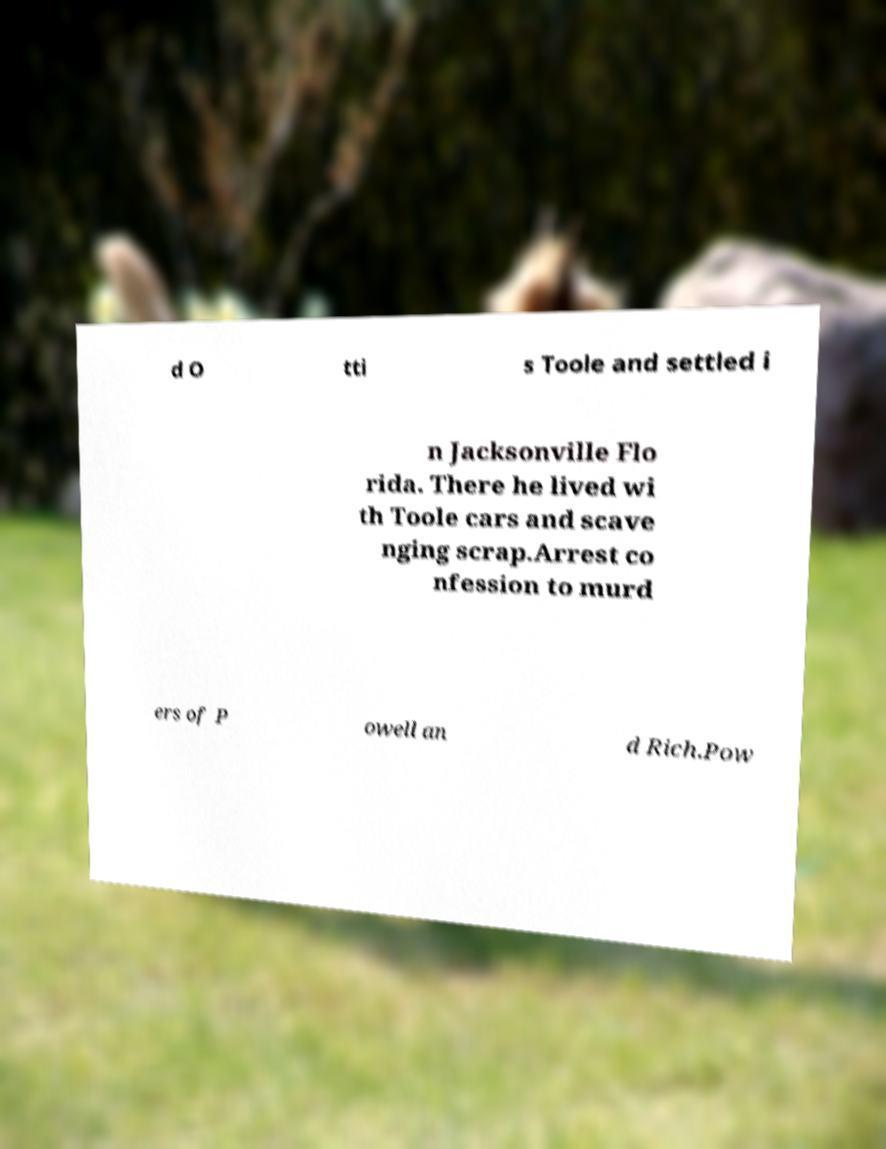I need the written content from this picture converted into text. Can you do that? d O tti s Toole and settled i n Jacksonville Flo rida. There he lived wi th Toole cars and scave nging scrap.Arrest co nfession to murd ers of P owell an d Rich.Pow 